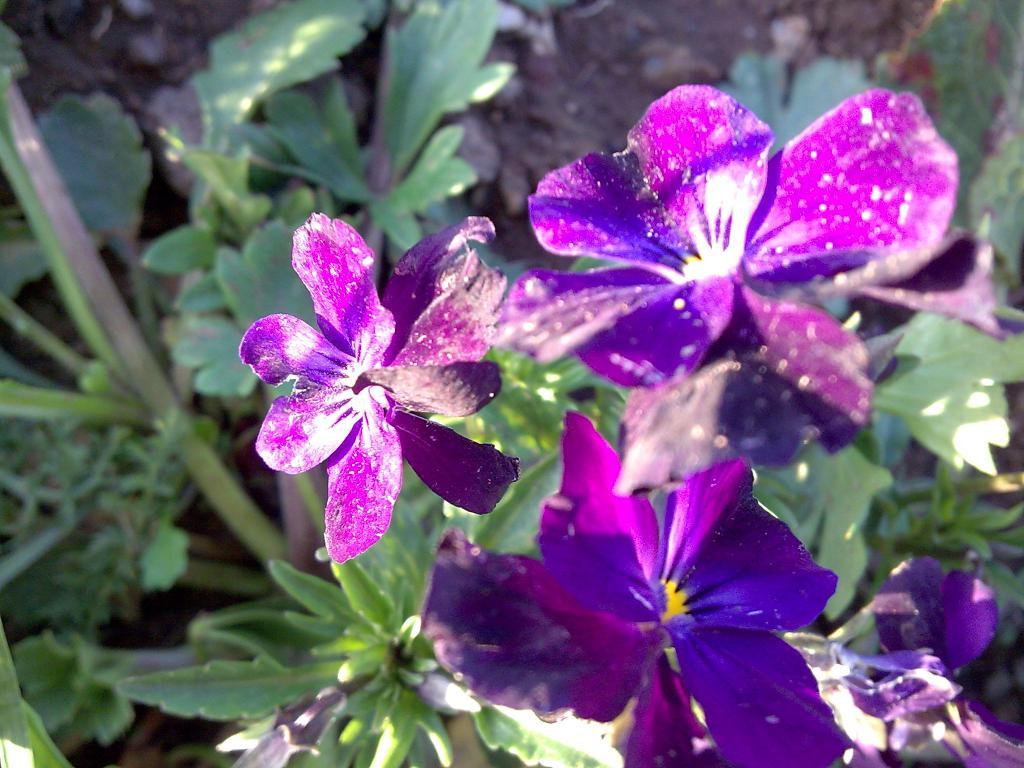What types of living organisms can be seen in the image? Plants and flowers are visible in the image. What part of the natural environment is visible in the image? The ground is visible in the image. What is the price of the memory card in the image? There is no memory card present in the image. Can you tell me how many seashores are visible in the image? There are no seashores visible in the image; it features plants and flowers. 